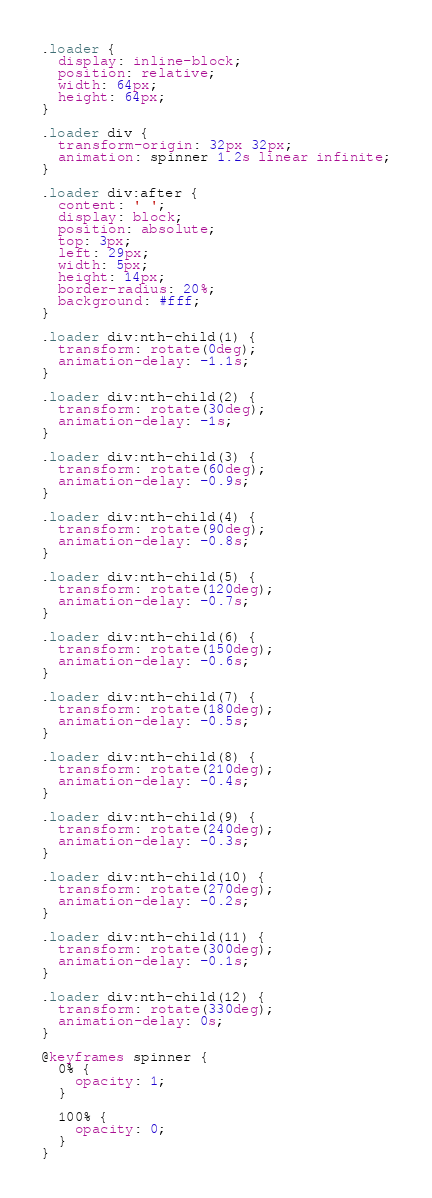Convert code to text. <code><loc_0><loc_0><loc_500><loc_500><_CSS_>.loader {
  display: inline-block;
  position: relative;
  width: 64px;
  height: 64px;
}

.loader div {
  transform-origin: 32px 32px;
  animation: spinner 1.2s linear infinite;
}

.loader div:after {
  content: ' ';
  display: block;
  position: absolute;
  top: 3px;
  left: 29px;
  width: 5px;
  height: 14px;
  border-radius: 20%;
  background: #fff;
}

.loader div:nth-child(1) {
  transform: rotate(0deg);
  animation-delay: -1.1s;
}

.loader div:nth-child(2) {
  transform: rotate(30deg);
  animation-delay: -1s;
}

.loader div:nth-child(3) {
  transform: rotate(60deg);
  animation-delay: -0.9s;
}

.loader div:nth-child(4) {
  transform: rotate(90deg);
  animation-delay: -0.8s;
}

.loader div:nth-child(5) {
  transform: rotate(120deg);
  animation-delay: -0.7s;
}

.loader div:nth-child(6) {
  transform: rotate(150deg);
  animation-delay: -0.6s;
}

.loader div:nth-child(7) {
  transform: rotate(180deg);
  animation-delay: -0.5s;
}

.loader div:nth-child(8) {
  transform: rotate(210deg);
  animation-delay: -0.4s;
}

.loader div:nth-child(9) {
  transform: rotate(240deg);
  animation-delay: -0.3s;
}

.loader div:nth-child(10) {
  transform: rotate(270deg);
  animation-delay: -0.2s;
}

.loader div:nth-child(11) {
  transform: rotate(300deg);
  animation-delay: -0.1s;
}

.loader div:nth-child(12) {
  transform: rotate(330deg);
  animation-delay: 0s;
}

@keyframes spinner {
  0% {
    opacity: 1;
  }

  100% {
    opacity: 0;
  }
}
</code> 